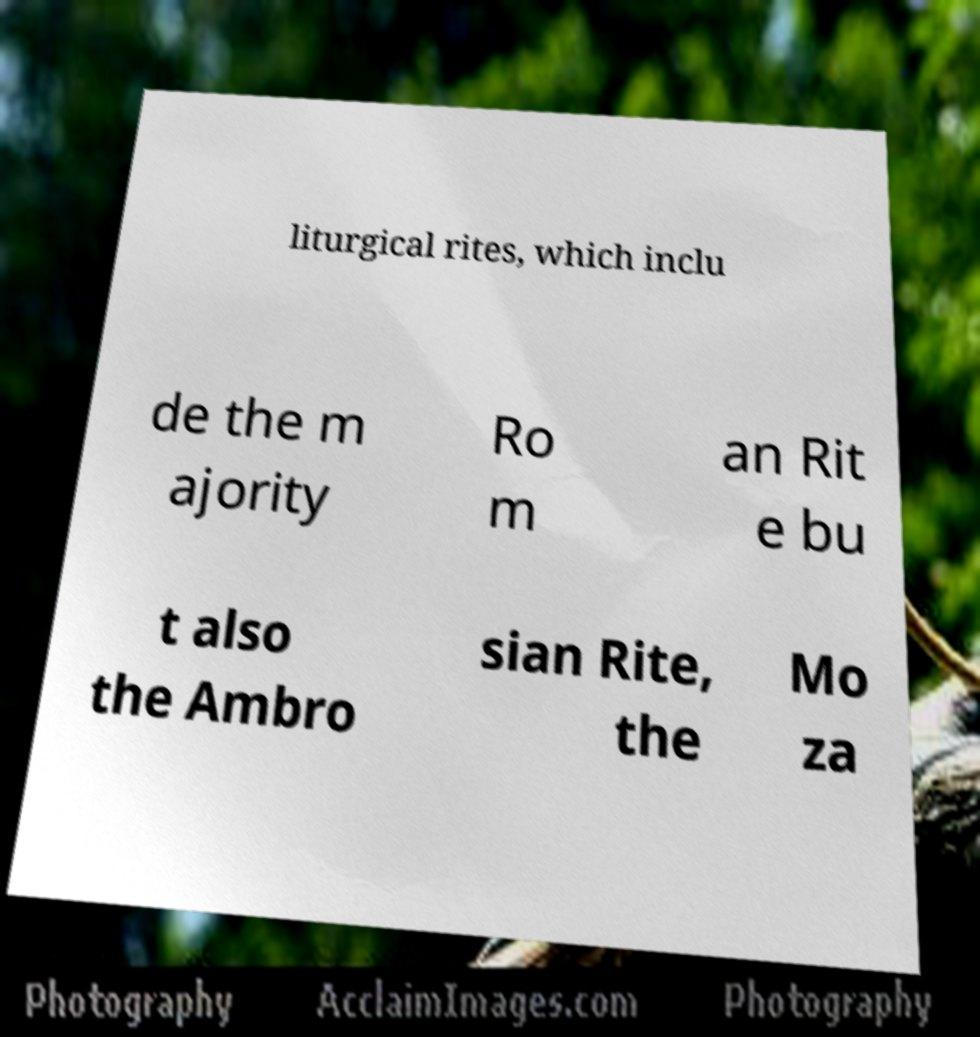Can you accurately transcribe the text from the provided image for me? liturgical rites, which inclu de the m ajority Ro m an Rit e bu t also the Ambro sian Rite, the Mo za 